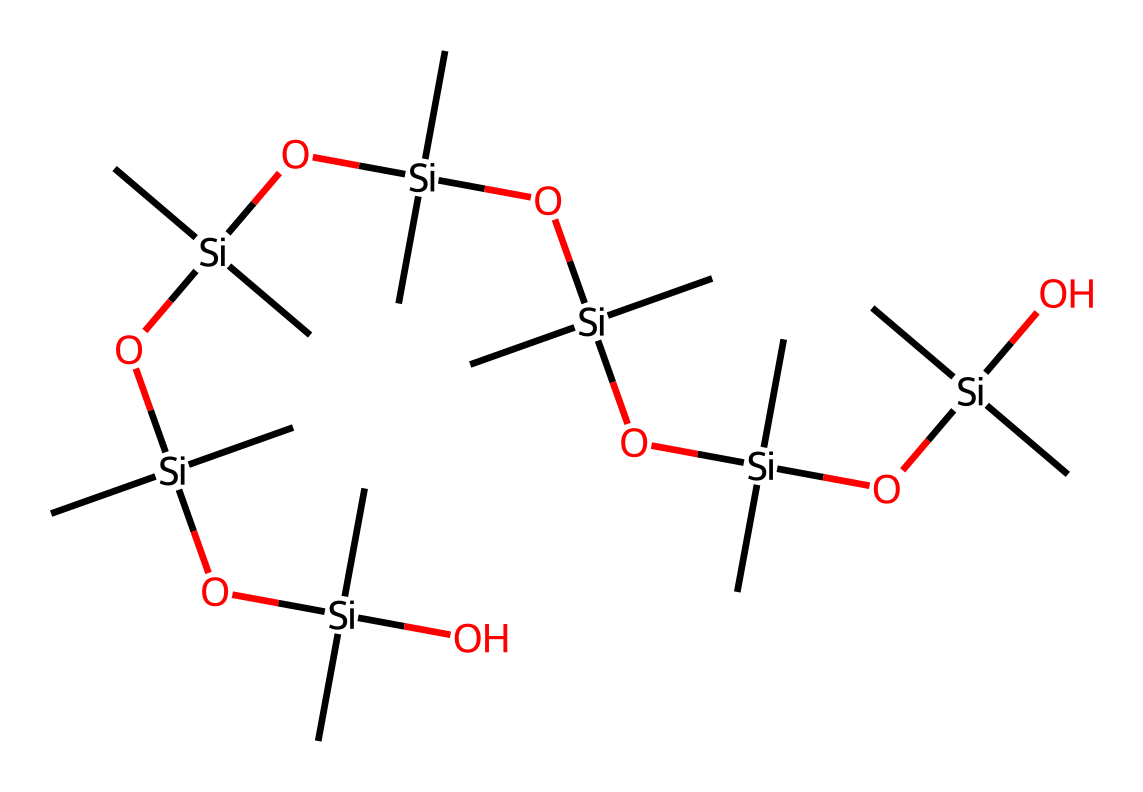what is the primary element present in this compound? The SMILES representation shows the presence of silicon (Si) as the primary element, as each branching point in the structure has silicon atoms.
Answer: silicon how many silicone (Si) atoms are in this structure? By counting the instances of Si in the SMILES representation, there are a total of 6 silicon atoms present in the chemical structure.
Answer: six how many carbon (C) atoms are found in this compound? The structure shows multiple carbon atoms attached to each silicon atom. Based on the branching seen in the SMILES, there are 18 carbon atoms present in total.
Answer: eighteen what aspect of this compound contributes to its flexibility? The presence of the long siloxane chains (Si-O bonds) allows for flexibility due to their ability to stretch and bend without breaking.
Answer: siloxane chains what is the general class of this chemical compound? This compound belongs to the class of organosilicon compounds due to its incorporation of silicon and organic groups together in the structure.
Answer: organosilicon how does the presence of oxygen (O) atoms affect its properties? The oxygen atoms in the siloxane linkages help to create a flexible, rubbery texture while also providing resistance to moisture and heat, which are valuable for teething toys.
Answer: flexibility and moisture resistance how is this chemical structure related to safety for infants? The structure includes non-toxic elements like silicon and carbon, which are generally considered safe for infants, making it suitable for teething toys.
Answer: non-toxic 